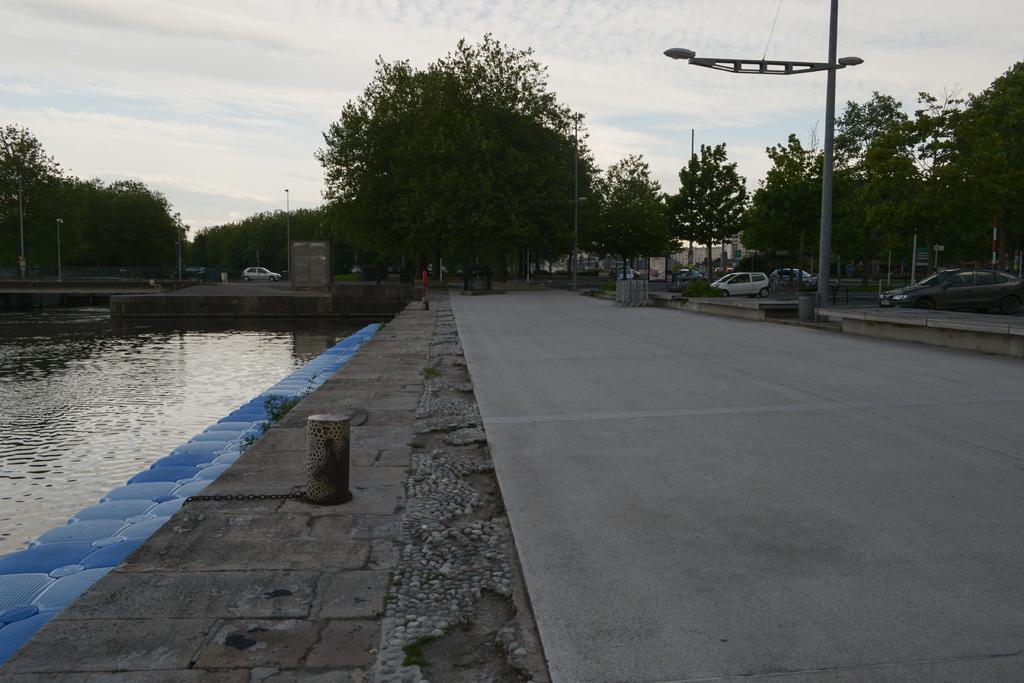How would you summarize this image in a sentence or two? On the left side there is water,bridge,poles,trees and vehicle. At the bottom there is a road,small pole and a chain on the left side. In the background there are trees,poles,light poles,vehicles and clouds in the sky. 